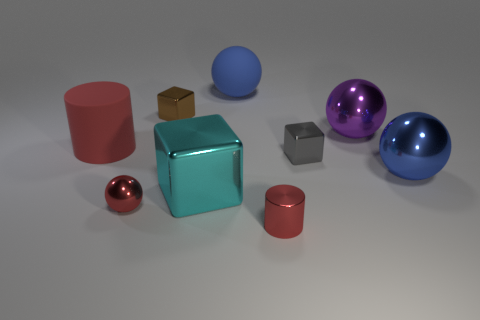Are there more small gray objects that are in front of the red metallic ball than large red rubber objects? After carefully reviewing the image, it seems that there are an equal number of small gray objects in front of the red metallic ball as there are large red rubber objects in total. Both quantities amount to two, making them equivalent in number. 